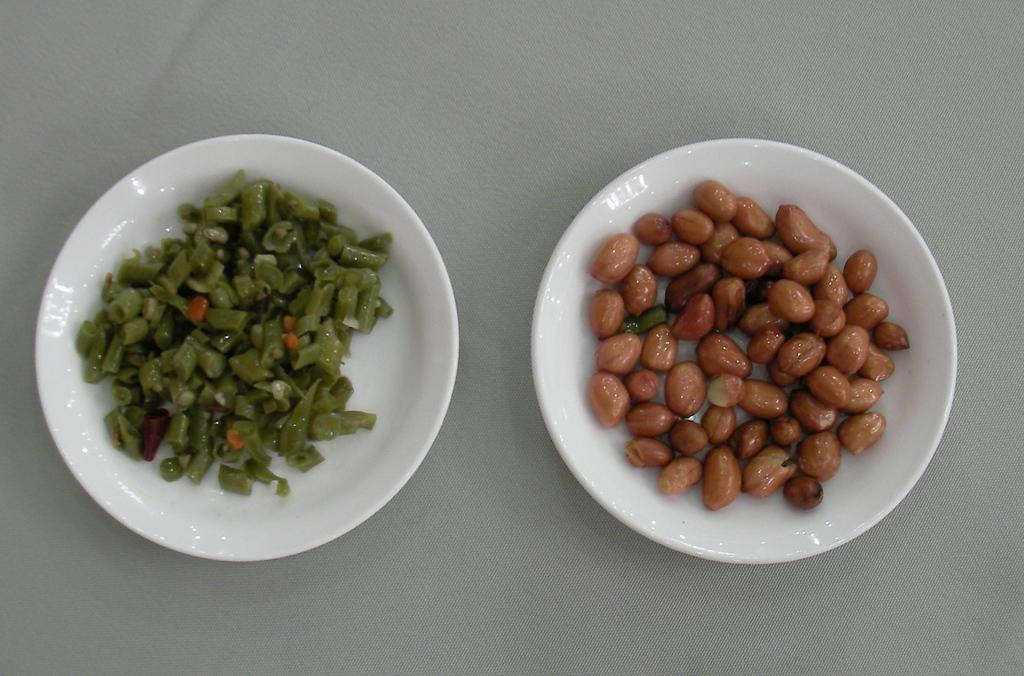What is in the bowl on the right side of the image? There is a bowl of peanuts on the right side of the image. What color is the bowl? The bowl is white. What is on the plate on the left side of the image? There are vegetable pieces on a plate on the left side of the image. What color is the plate? The plate is white. What type of powder can be seen on the ground in the image? There is no powder or ground visible in the image; it only features a bowl of peanuts and a plate of vegetable pieces. 